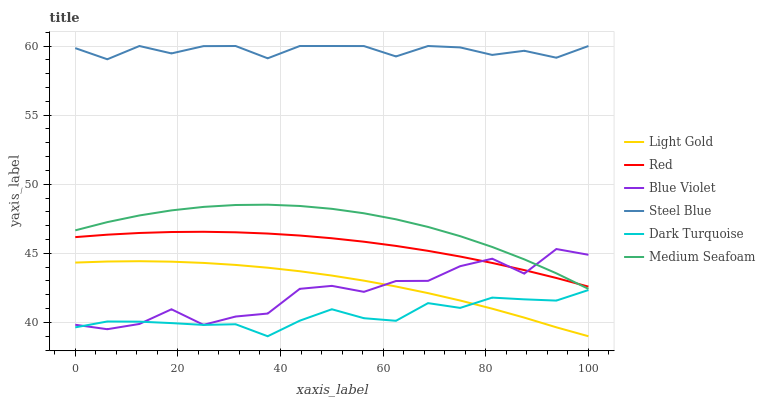Does Dark Turquoise have the minimum area under the curve?
Answer yes or no. Yes. Does Steel Blue have the maximum area under the curve?
Answer yes or no. Yes. Does Red have the minimum area under the curve?
Answer yes or no. No. Does Red have the maximum area under the curve?
Answer yes or no. No. Is Red the smoothest?
Answer yes or no. Yes. Is Blue Violet the roughest?
Answer yes or no. Yes. Is Steel Blue the smoothest?
Answer yes or no. No. Is Steel Blue the roughest?
Answer yes or no. No. Does Red have the lowest value?
Answer yes or no. No. Does Steel Blue have the highest value?
Answer yes or no. Yes. Does Red have the highest value?
Answer yes or no. No. Is Light Gold less than Medium Seafoam?
Answer yes or no. Yes. Is Medium Seafoam greater than Light Gold?
Answer yes or no. Yes. Does Blue Violet intersect Medium Seafoam?
Answer yes or no. Yes. Is Blue Violet less than Medium Seafoam?
Answer yes or no. No. Is Blue Violet greater than Medium Seafoam?
Answer yes or no. No. Does Light Gold intersect Medium Seafoam?
Answer yes or no. No. 